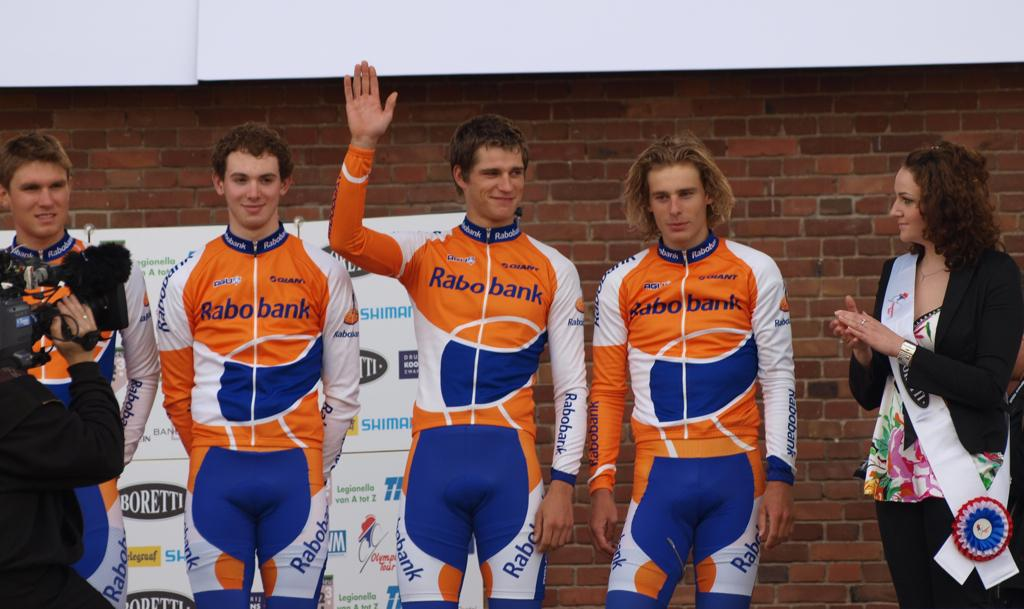<image>
Offer a succinct explanation of the picture presented. Men in jumpsuit uniforms sponsored by Rabobank pose in a line. 